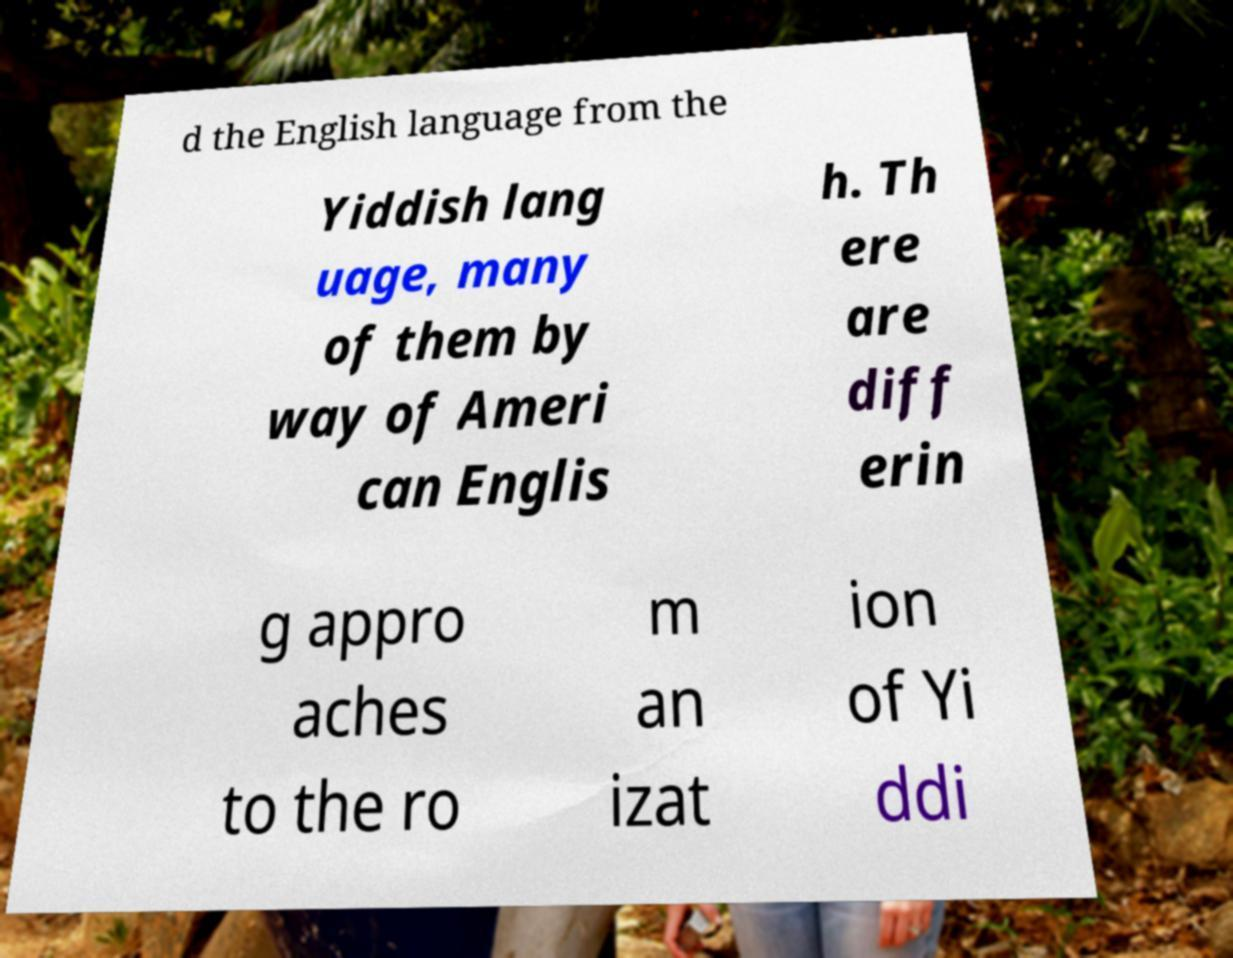There's text embedded in this image that I need extracted. Can you transcribe it verbatim? d the English language from the Yiddish lang uage, many of them by way of Ameri can Englis h. Th ere are diff erin g appro aches to the ro m an izat ion of Yi ddi 